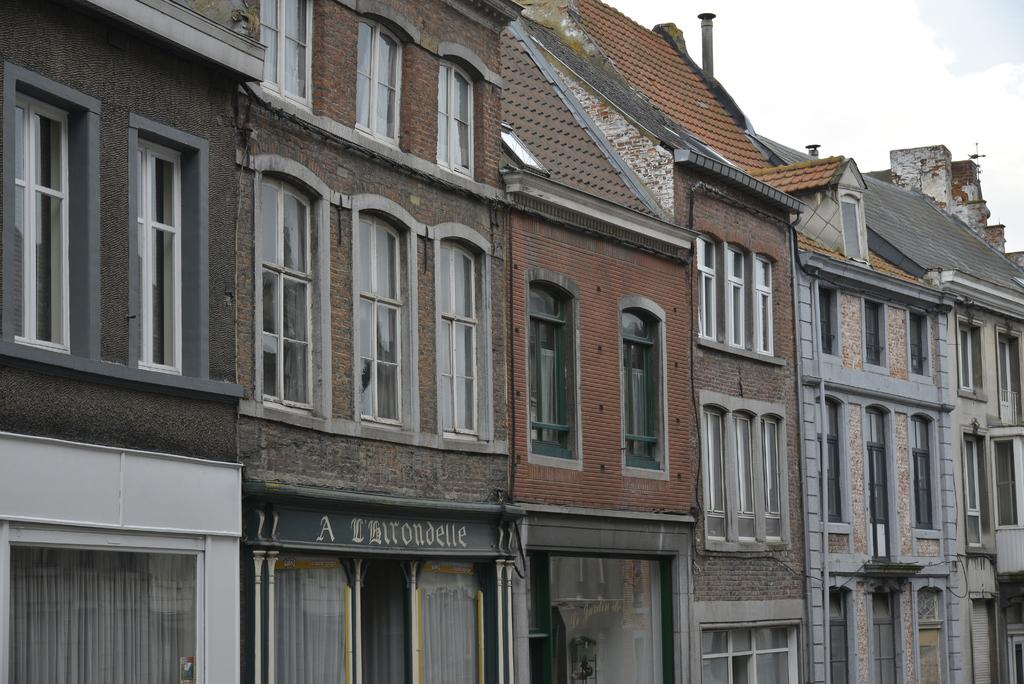What type of structure is in the image? There is a building in the image. What feature can be seen on the building? The building has windows. What can be seen in the background of the image? There is sky visible in the background of the image. What is present in the sky? Clouds are present in the sky. What type of care is provided for the gate in the image? There is no gate present in the image, so there is no care provided for it. 